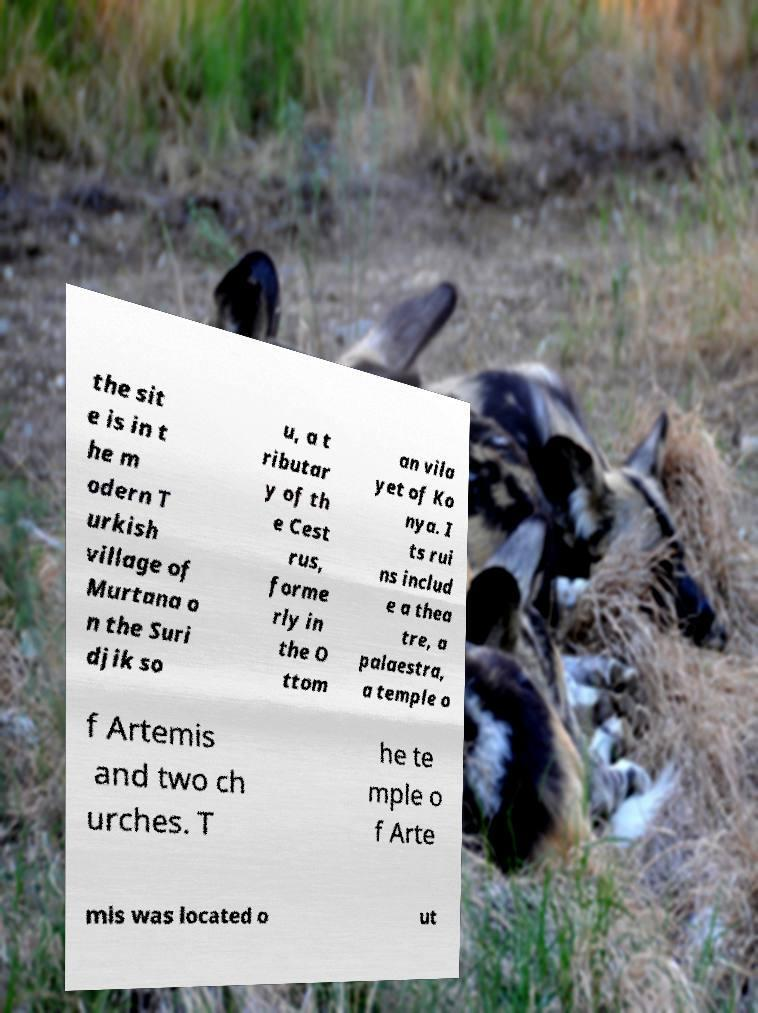Please read and relay the text visible in this image. What does it say? the sit e is in t he m odern T urkish village of Murtana o n the Suri djik so u, a t ributar y of th e Cest rus, forme rly in the O ttom an vila yet of Ko nya. I ts rui ns includ e a thea tre, a palaestra, a temple o f Artemis and two ch urches. T he te mple o f Arte mis was located o ut 